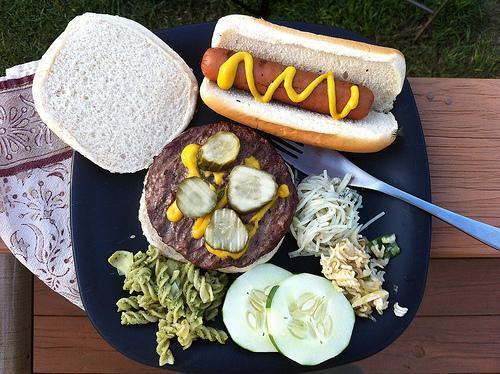How many cucumber slices?
Give a very brief answer. 2. 